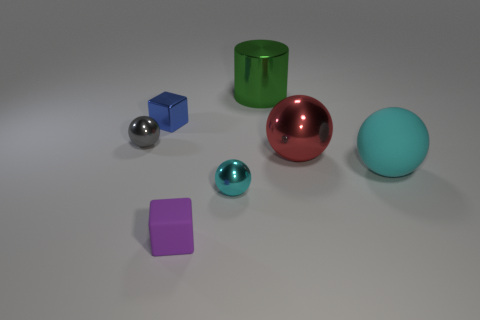How many balls have the same color as the large rubber object?
Your response must be concise. 1. Are there any other tiny objects that have the same material as the blue object?
Provide a succinct answer. Yes. There is a tiny sphere behind the red thing; what is its material?
Your response must be concise. Metal. There is a object to the right of the big red metallic ball; is its color the same as the small metal object on the right side of the purple matte thing?
Ensure brevity in your answer.  Yes. The rubber cube that is the same size as the gray object is what color?
Keep it short and to the point. Purple. How many other objects are the same shape as the green thing?
Keep it short and to the point. 0. How big is the matte object that is behind the tiny cyan thing?
Offer a very short reply. Large. There is a big metal thing that is behind the gray metal object; how many large cylinders are left of it?
Provide a succinct answer. 0. How many other things are there of the same size as the cyan metallic ball?
Offer a very short reply. 3. Does the tiny thing in front of the small cyan metal object have the same shape as the blue shiny thing?
Provide a succinct answer. Yes. 